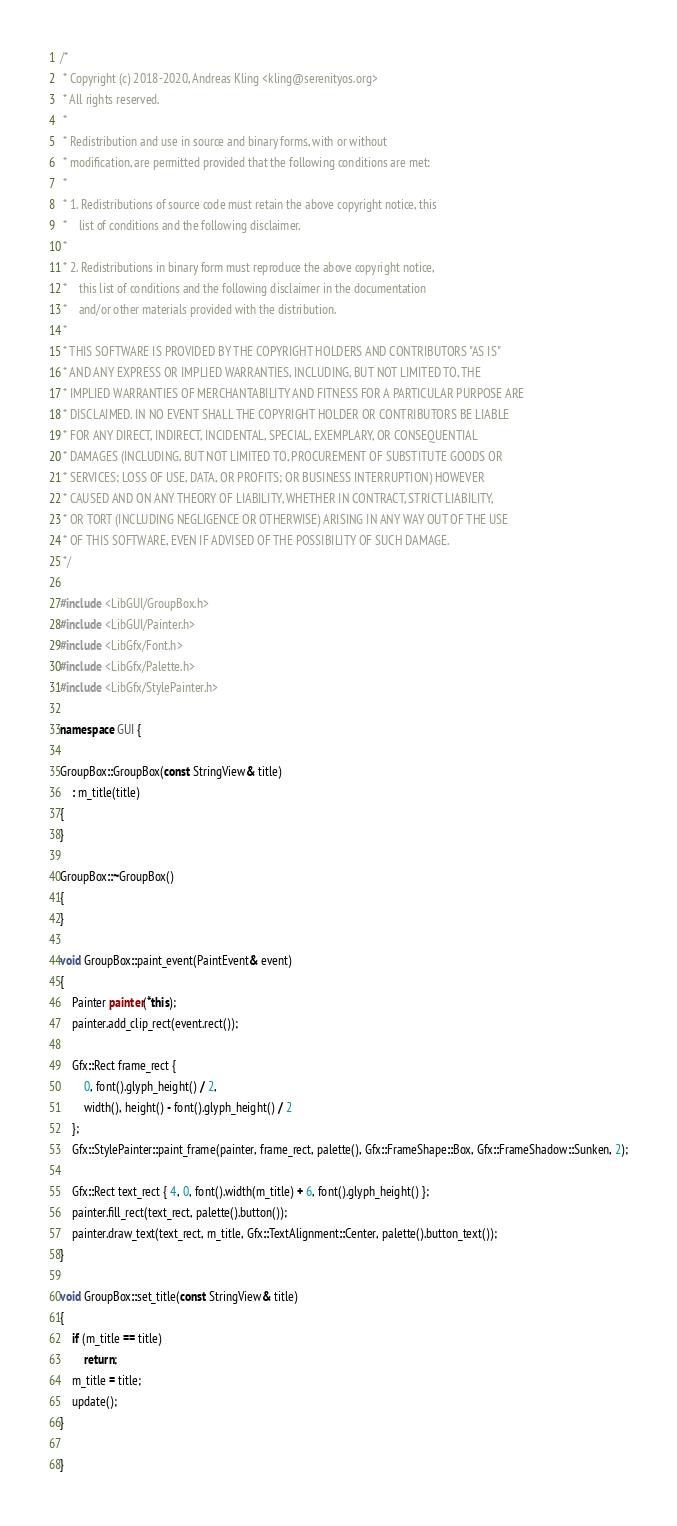Convert code to text. <code><loc_0><loc_0><loc_500><loc_500><_C++_>/*
 * Copyright (c) 2018-2020, Andreas Kling <kling@serenityos.org>
 * All rights reserved.
 *
 * Redistribution and use in source and binary forms, with or without
 * modification, are permitted provided that the following conditions are met:
 *
 * 1. Redistributions of source code must retain the above copyright notice, this
 *    list of conditions and the following disclaimer.
 *
 * 2. Redistributions in binary form must reproduce the above copyright notice,
 *    this list of conditions and the following disclaimer in the documentation
 *    and/or other materials provided with the distribution.
 *
 * THIS SOFTWARE IS PROVIDED BY THE COPYRIGHT HOLDERS AND CONTRIBUTORS "AS IS"
 * AND ANY EXPRESS OR IMPLIED WARRANTIES, INCLUDING, BUT NOT LIMITED TO, THE
 * IMPLIED WARRANTIES OF MERCHANTABILITY AND FITNESS FOR A PARTICULAR PURPOSE ARE
 * DISCLAIMED. IN NO EVENT SHALL THE COPYRIGHT HOLDER OR CONTRIBUTORS BE LIABLE
 * FOR ANY DIRECT, INDIRECT, INCIDENTAL, SPECIAL, EXEMPLARY, OR CONSEQUENTIAL
 * DAMAGES (INCLUDING, BUT NOT LIMITED TO, PROCUREMENT OF SUBSTITUTE GOODS OR
 * SERVICES; LOSS OF USE, DATA, OR PROFITS; OR BUSINESS INTERRUPTION) HOWEVER
 * CAUSED AND ON ANY THEORY OF LIABILITY, WHETHER IN CONTRACT, STRICT LIABILITY,
 * OR TORT (INCLUDING NEGLIGENCE OR OTHERWISE) ARISING IN ANY WAY OUT OF THE USE
 * OF THIS SOFTWARE, EVEN IF ADVISED OF THE POSSIBILITY OF SUCH DAMAGE.
 */

#include <LibGUI/GroupBox.h>
#include <LibGUI/Painter.h>
#include <LibGfx/Font.h>
#include <LibGfx/Palette.h>
#include <LibGfx/StylePainter.h>

namespace GUI {

GroupBox::GroupBox(const StringView& title)
    : m_title(title)
{
}

GroupBox::~GroupBox()
{
}

void GroupBox::paint_event(PaintEvent& event)
{
    Painter painter(*this);
    painter.add_clip_rect(event.rect());

    Gfx::Rect frame_rect {
        0, font().glyph_height() / 2,
        width(), height() - font().glyph_height() / 2
    };
    Gfx::StylePainter::paint_frame(painter, frame_rect, palette(), Gfx::FrameShape::Box, Gfx::FrameShadow::Sunken, 2);

    Gfx::Rect text_rect { 4, 0, font().width(m_title) + 6, font().glyph_height() };
    painter.fill_rect(text_rect, palette().button());
    painter.draw_text(text_rect, m_title, Gfx::TextAlignment::Center, palette().button_text());
}

void GroupBox::set_title(const StringView& title)
{
    if (m_title == title)
        return;
    m_title = title;
    update();
}

}
</code> 